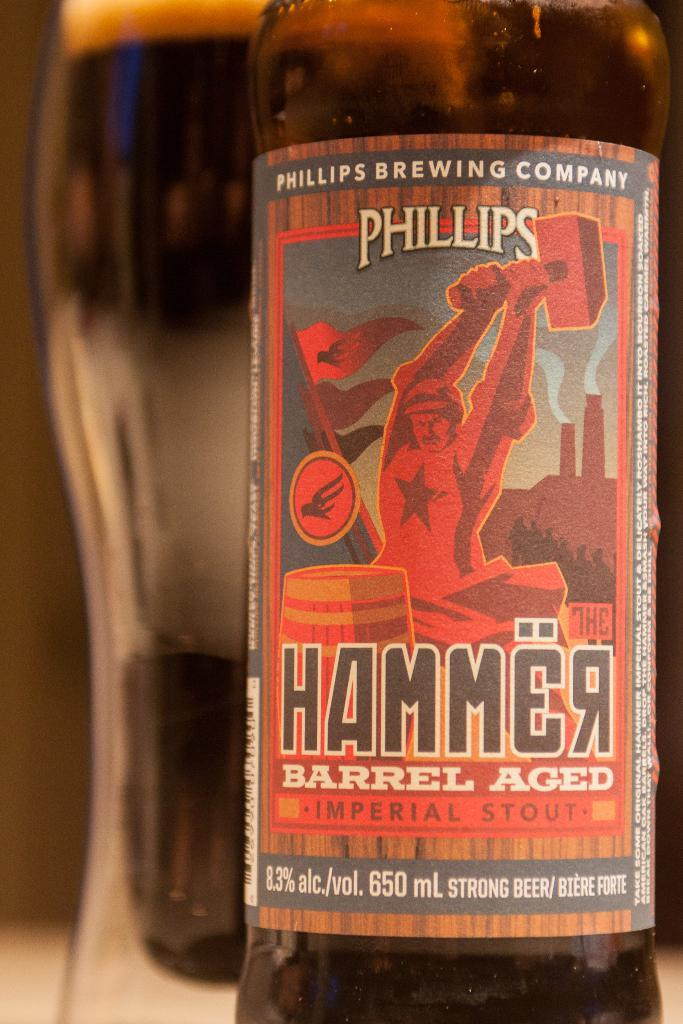What objects are present in the image? There are bottles in the image. Can you describe any specific details about the bottles? Yes, there is a sticker on one of the bottles. What type of vegetable can be seen growing in the background of the image? There is no vegetable visible in the image; it only features bottles with a sticker on one of them. 